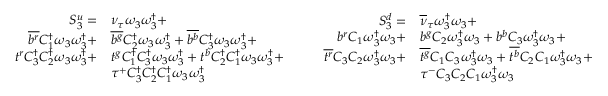Convert formula to latex. <formula><loc_0><loc_0><loc_500><loc_500>\begin{array} { r l } { S _ { 3 } ^ { u } = } & { { \nu _ { \tau } } \omega _ { 3 } \omega _ { 3 } ^ { \dagger } + } \\ { \overline { { b ^ { r } } } { C _ { 1 } ^ { \dagger } } \omega _ { 3 } \omega _ { 3 } ^ { \dagger } + } & { \overline { { b ^ { g } } } { C _ { 2 } ^ { \dagger } } \omega _ { 3 } \omega _ { 3 } ^ { \dagger } + \overline { { b ^ { b } } } { C _ { 3 } ^ { \dagger } } \omega _ { 3 } \omega _ { 3 } ^ { \dagger } + } \\ { t ^ { r } { C _ { 3 } ^ { \dagger } } { C _ { 2 } ^ { \dagger } } \omega _ { 3 } \omega _ { 3 } ^ { \dagger } + } & { t ^ { g } { C _ { 1 } ^ { \dagger } } { C _ { 3 } ^ { \dagger } } \omega _ { 3 } \omega _ { 3 } ^ { \dagger } + t ^ { b } { C _ { 2 } ^ { \dagger } } { C _ { 1 } ^ { \dagger } } \omega _ { 3 } \omega _ { 3 } ^ { \dagger } + } \\ & { \tau ^ { + } { C _ { 3 } ^ { \dagger } } { C _ { 2 } ^ { \dagger } } { C _ { 1 } ^ { \dagger } } \omega _ { 3 } \omega _ { 3 } ^ { \dagger } } \end{array} \quad \begin{array} { r l } { S _ { 3 } ^ { d } = } & { { \overline { \nu } _ { \tau } } \omega _ { 3 } ^ { \dagger } \omega _ { 3 } + } \\ { { b } ^ { r } { C _ { 1 } } \omega _ { 3 } ^ { \dagger } \omega _ { 3 } + } & { { b } ^ { g } { C _ { 2 } } \omega _ { 3 } ^ { \dagger } \omega _ { 3 } + { b } ^ { b } { C _ { 3 } } \omega _ { 3 } ^ { \dagger } \omega _ { 3 } + } \\ { \overline { { t ^ { r } } } { C _ { 3 } } { C _ { 2 } } \omega _ { 3 } ^ { \dagger } \omega _ { 3 } + } & { \overline { { t ^ { g } } } { C _ { 1 } } { C _ { 3 } } \omega _ { 3 } ^ { \dagger } \omega _ { 3 } + \overline { { t ^ { b } } } { C _ { 2 } } { C _ { 1 } } \omega _ { 3 } ^ { \dagger } \omega _ { 3 } + } \\ & { \tau ^ { - } { C _ { 3 } } { C _ { 2 } } { C _ { 1 } } \omega _ { 3 } ^ { \dagger } \omega _ { 3 } } \end{array}</formula> 